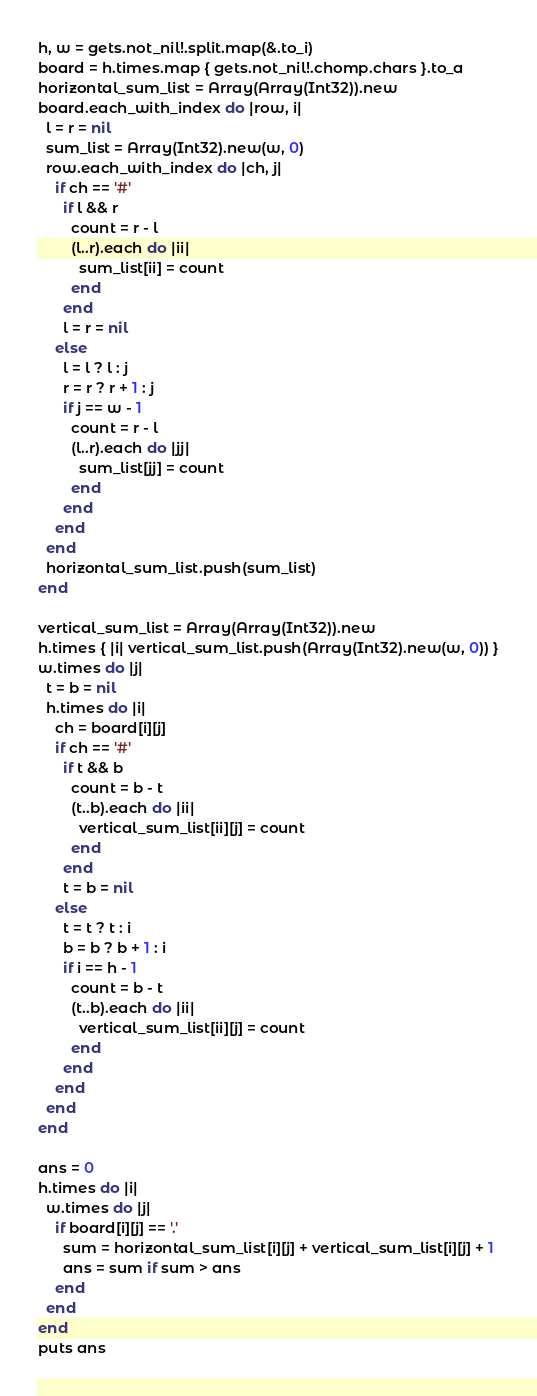Convert code to text. <code><loc_0><loc_0><loc_500><loc_500><_Crystal_>h, w = gets.not_nil!.split.map(&.to_i)
board = h.times.map { gets.not_nil!.chomp.chars }.to_a
horizontal_sum_list = Array(Array(Int32)).new
board.each_with_index do |row, i|
  l = r = nil
  sum_list = Array(Int32).new(w, 0)
  row.each_with_index do |ch, j|
    if ch == '#'
      if l && r
        count = r - l
        (l..r).each do |ii|
          sum_list[ii] = count
        end
      end
      l = r = nil
    else
      l = l ? l : j
      r = r ? r + 1 : j
      if j == w - 1
        count = r - l
        (l..r).each do |jj|
          sum_list[jj] = count
        end
      end
    end
  end
  horizontal_sum_list.push(sum_list)
end

vertical_sum_list = Array(Array(Int32)).new
h.times { |i| vertical_sum_list.push(Array(Int32).new(w, 0)) }
w.times do |j|
  t = b = nil
  h.times do |i|
    ch = board[i][j]
    if ch == '#'
      if t && b
        count = b - t
        (t..b).each do |ii|
          vertical_sum_list[ii][j] = count
        end
      end
      t = b = nil
    else
      t = t ? t : i
      b = b ? b + 1 : i
      if i == h - 1
        count = b - t
        (t..b).each do |ii|
          vertical_sum_list[ii][j] = count
        end
      end
    end
  end
end

ans = 0
h.times do |i|
  w.times do |j|
    if board[i][j] == '.'
      sum = horizontal_sum_list[i][j] + vertical_sum_list[i][j] + 1
      ans = sum if sum > ans
    end
  end
end
puts ans
</code> 